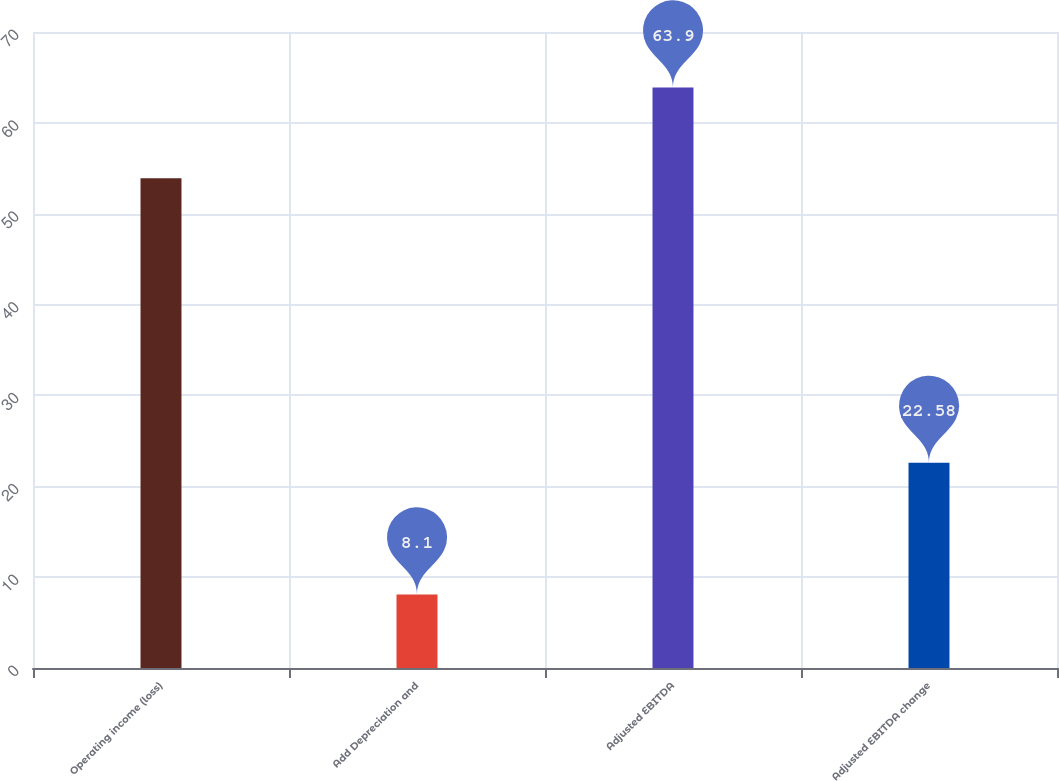Convert chart to OTSL. <chart><loc_0><loc_0><loc_500><loc_500><bar_chart><fcel>Operating income (loss)<fcel>Add Depreciation and<fcel>Adjusted EBITDA<fcel>Adjusted EBITDA change<nl><fcel>53.9<fcel>8.1<fcel>63.9<fcel>22.58<nl></chart> 